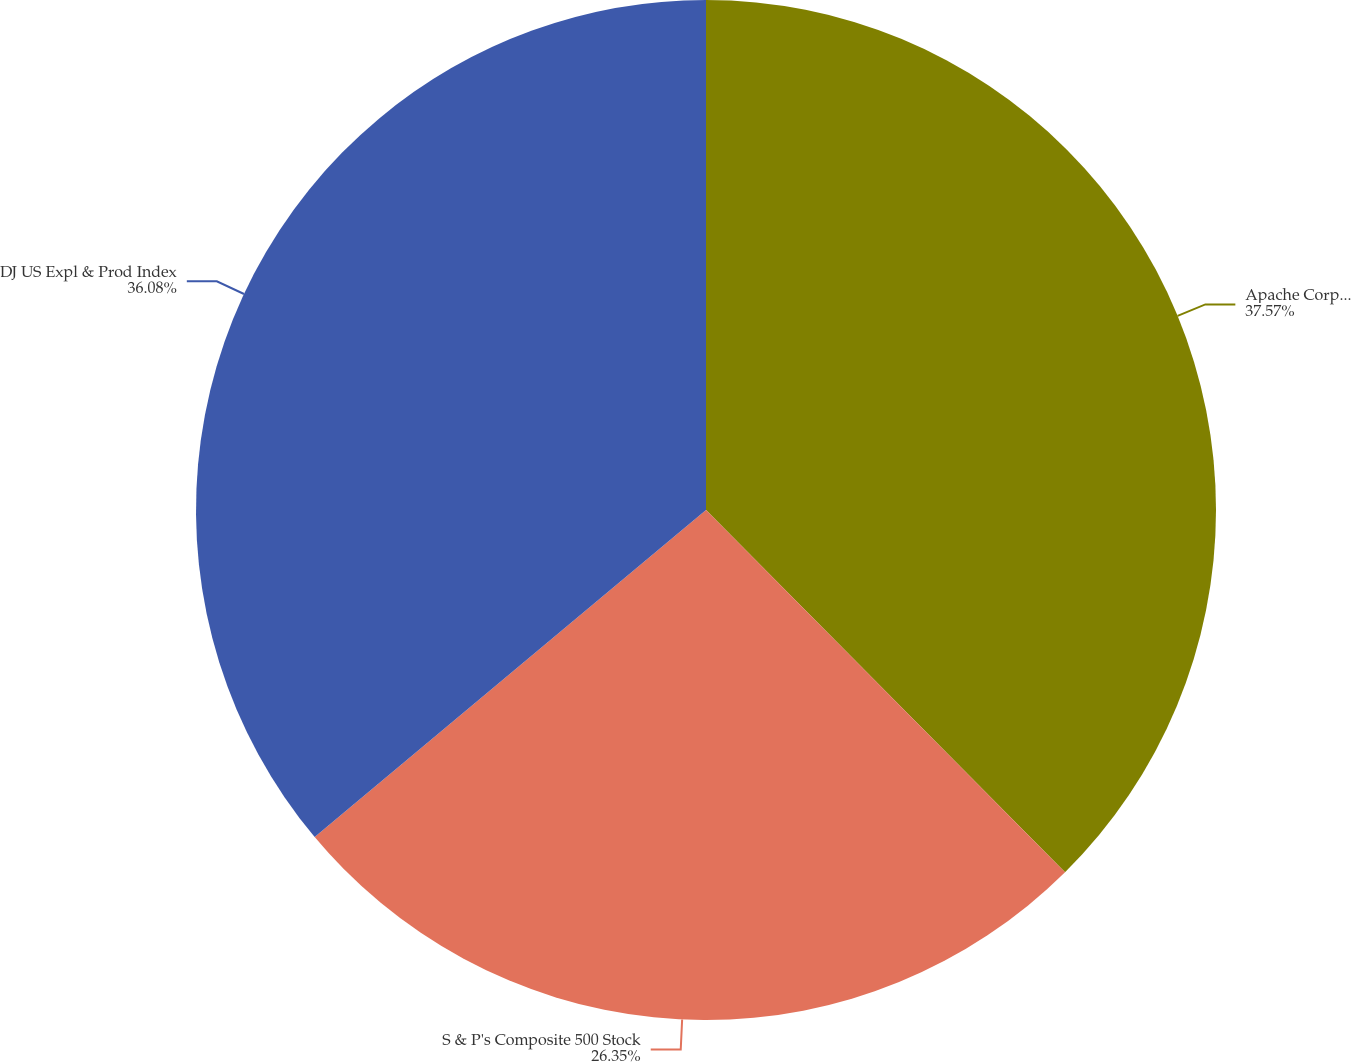Convert chart to OTSL. <chart><loc_0><loc_0><loc_500><loc_500><pie_chart><fcel>Apache Corporation<fcel>S & P's Composite 500 Stock<fcel>DJ US Expl & Prod Index<nl><fcel>37.57%<fcel>26.35%<fcel>36.08%<nl></chart> 